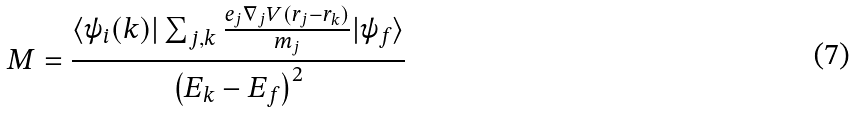<formula> <loc_0><loc_0><loc_500><loc_500>M = \frac { \langle \psi _ { i } ( k ) | \sum _ { j , k } \frac { e _ { j } \nabla _ { j } V ( r _ { j } - r _ { k } ) } { m _ { j } } | \psi _ { f } \rangle } { \left ( E _ { k } - E _ { f } \right ) ^ { 2 } }</formula> 